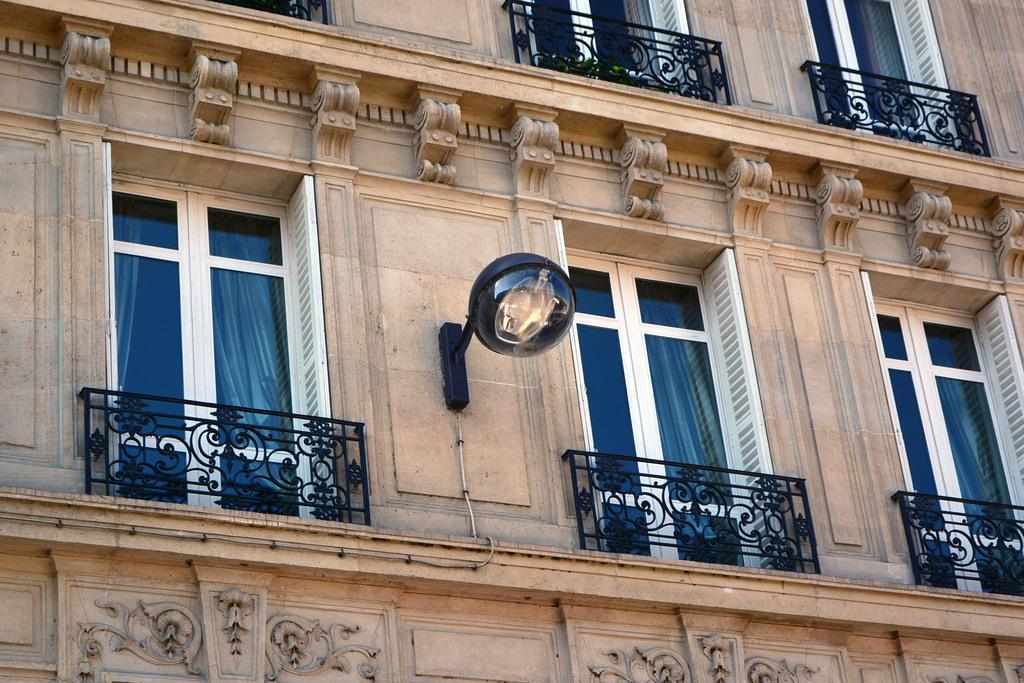How would you summarize this image in a sentence or two? In this picture I can see a building with windows, grills and also there is a light attached to the wall. 